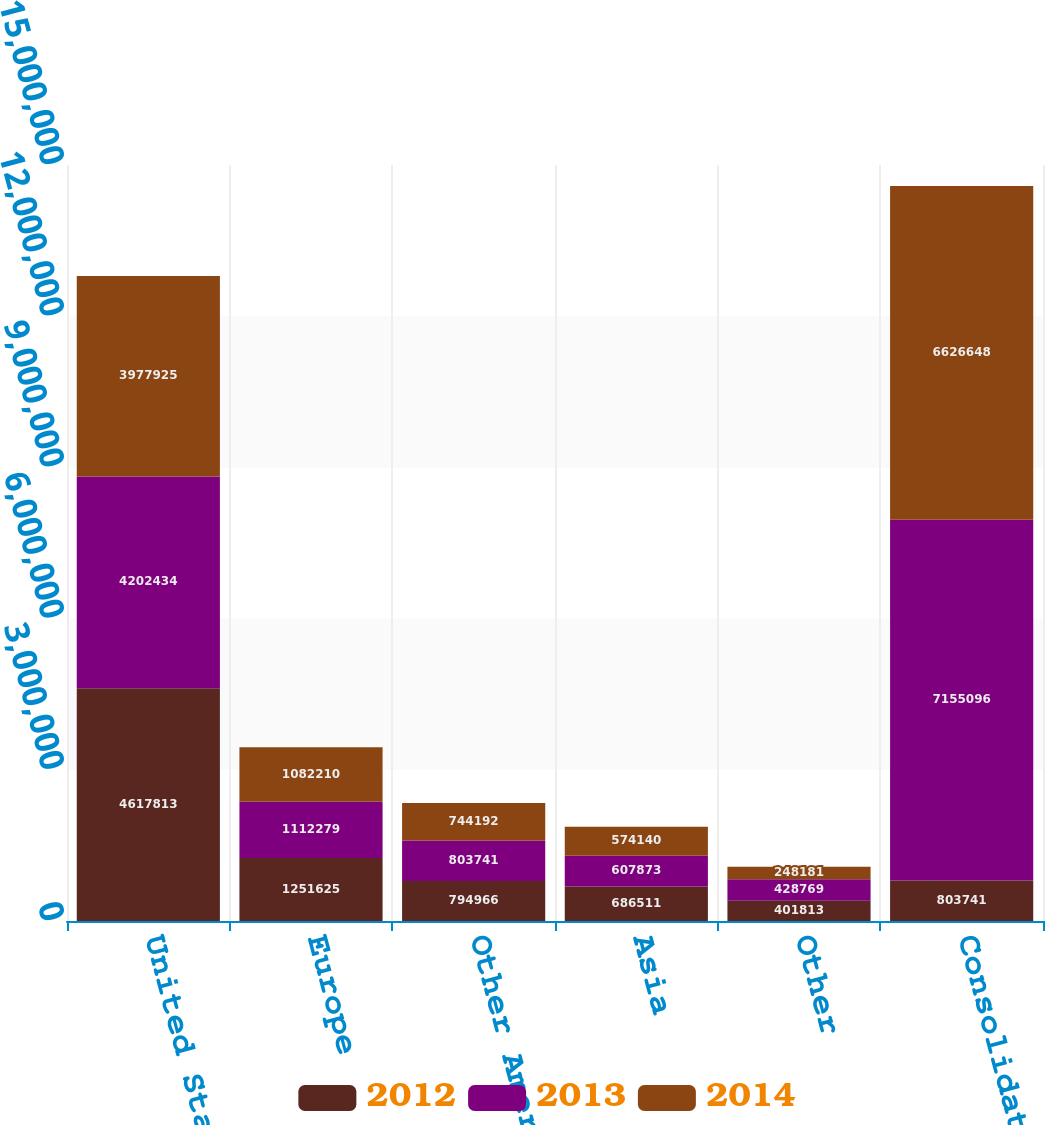<chart> <loc_0><loc_0><loc_500><loc_500><stacked_bar_chart><ecel><fcel>United States<fcel>Europe<fcel>Other Americas<fcel>Asia<fcel>Other<fcel>Consolidated total<nl><fcel>2012<fcel>4.61781e+06<fcel>1.25162e+06<fcel>794966<fcel>686511<fcel>401813<fcel>803741<nl><fcel>2013<fcel>4.20243e+06<fcel>1.11228e+06<fcel>803741<fcel>607873<fcel>428769<fcel>7.1551e+06<nl><fcel>2014<fcel>3.97792e+06<fcel>1.08221e+06<fcel>744192<fcel>574140<fcel>248181<fcel>6.62665e+06<nl></chart> 